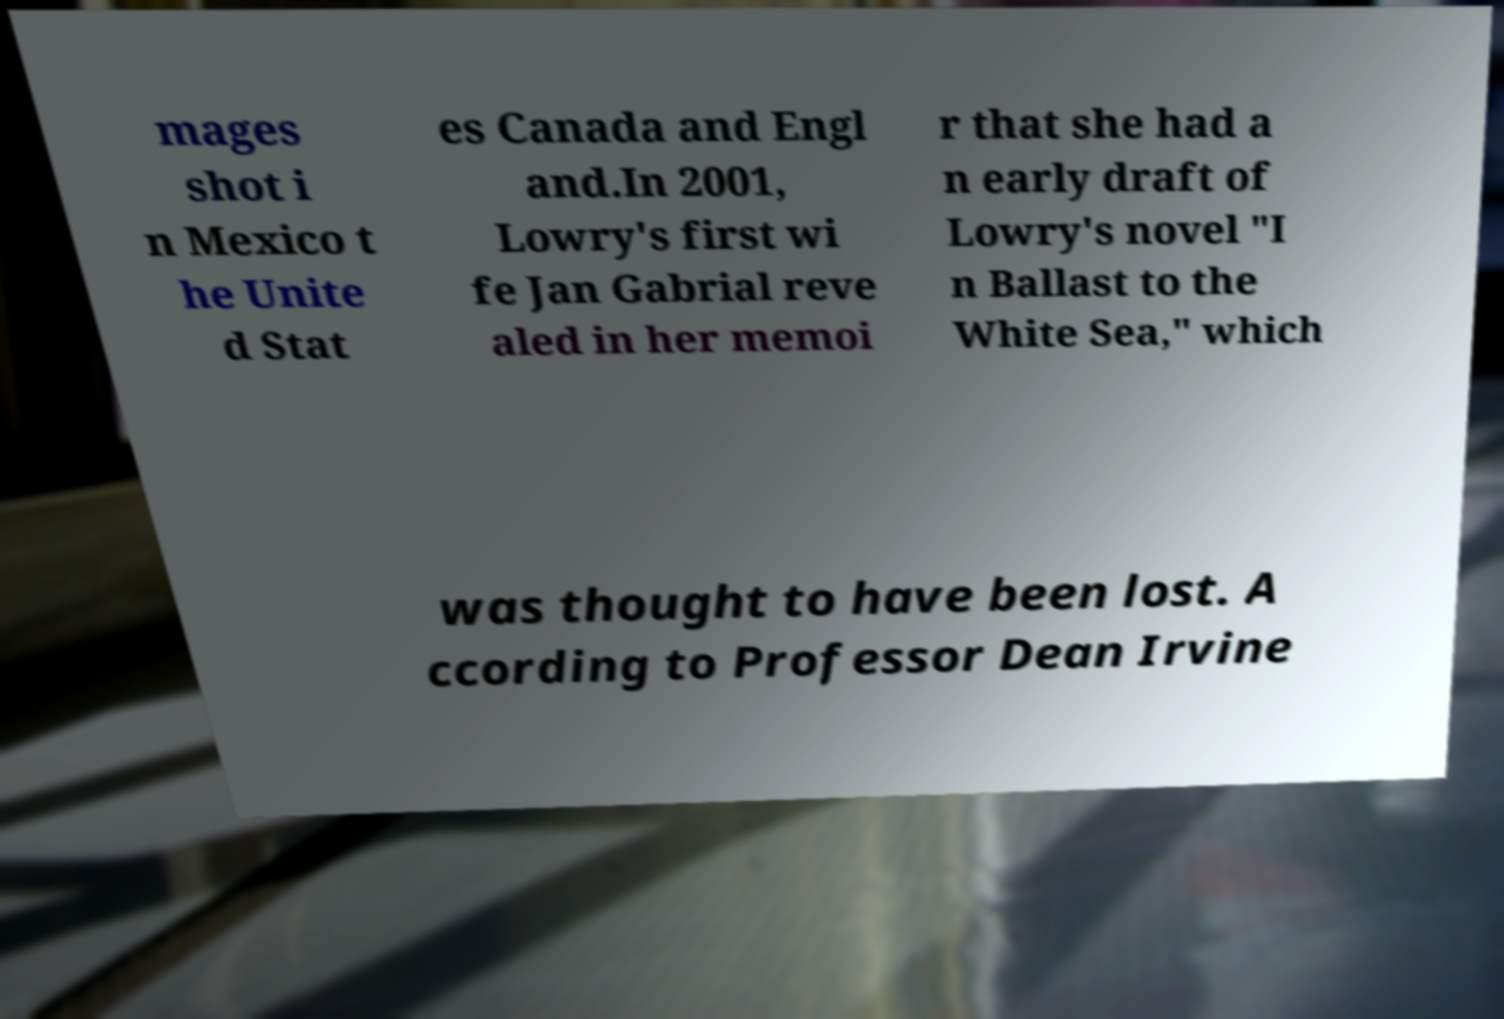Could you assist in decoding the text presented in this image and type it out clearly? mages shot i n Mexico t he Unite d Stat es Canada and Engl and.In 2001, Lowry's first wi fe Jan Gabrial reve aled in her memoi r that she had a n early draft of Lowry's novel "I n Ballast to the White Sea," which was thought to have been lost. A ccording to Professor Dean Irvine 